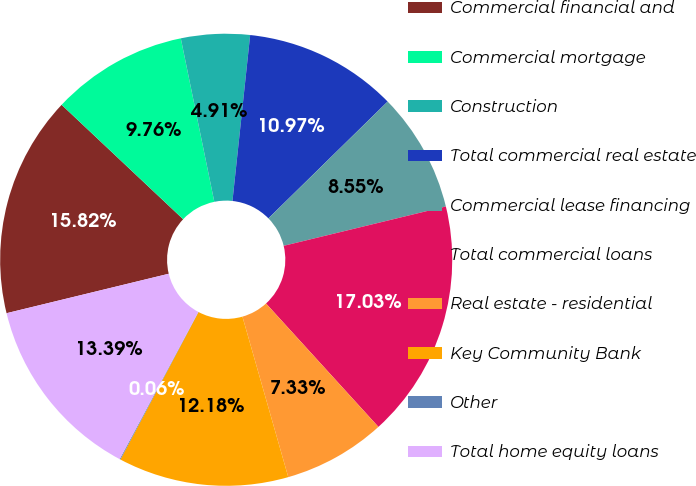Convert chart to OTSL. <chart><loc_0><loc_0><loc_500><loc_500><pie_chart><fcel>Commercial financial and<fcel>Commercial mortgage<fcel>Construction<fcel>Total commercial real estate<fcel>Commercial lease financing<fcel>Total commercial loans<fcel>Real estate - residential<fcel>Key Community Bank<fcel>Other<fcel>Total home equity loans<nl><fcel>15.82%<fcel>9.76%<fcel>4.91%<fcel>10.97%<fcel>8.55%<fcel>17.03%<fcel>7.33%<fcel>12.18%<fcel>0.06%<fcel>13.39%<nl></chart> 